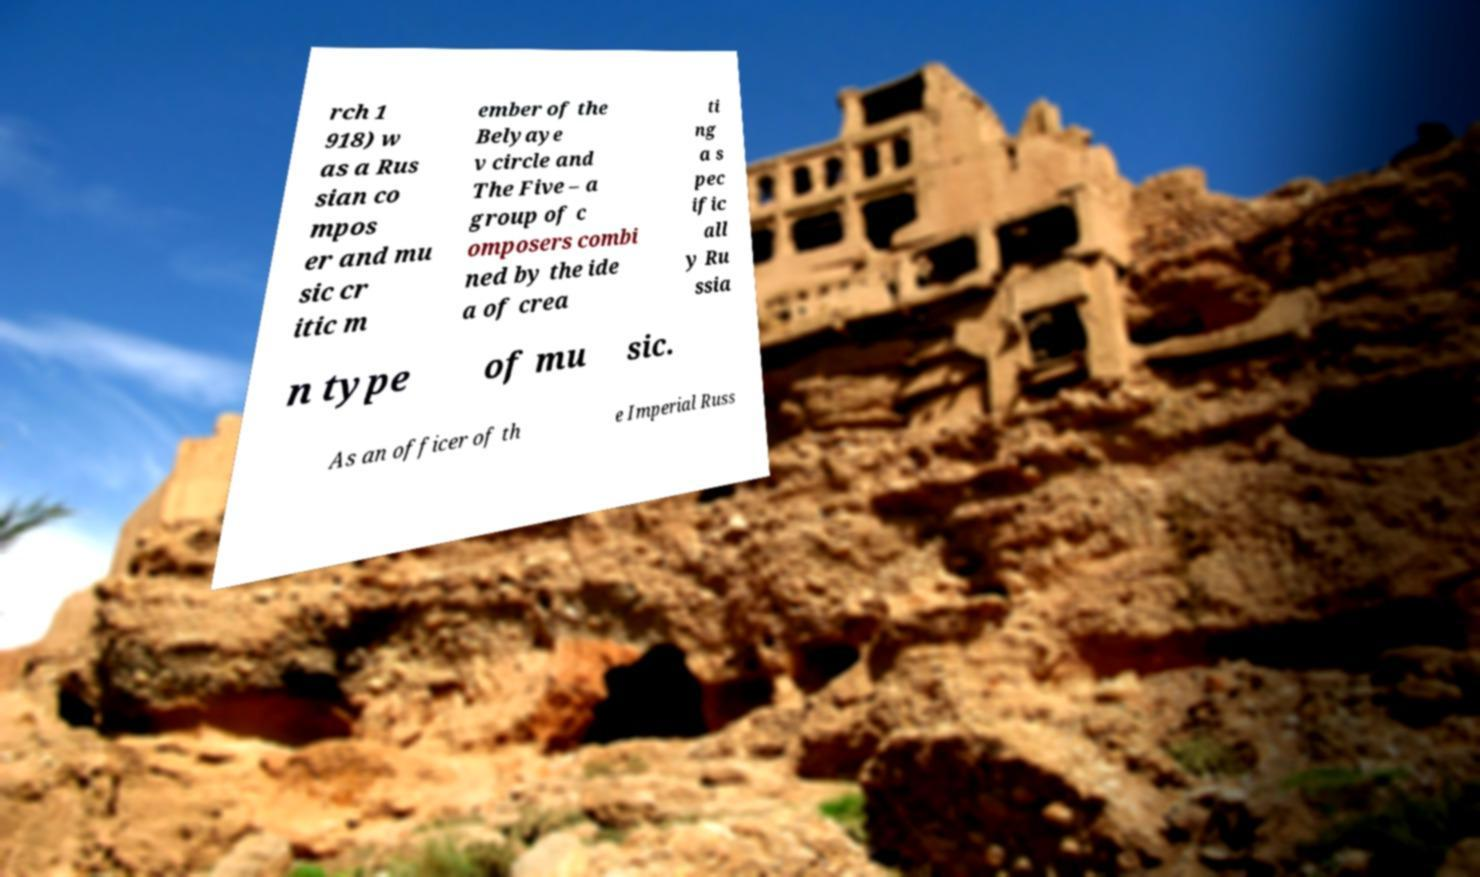Please identify and transcribe the text found in this image. rch 1 918) w as a Rus sian co mpos er and mu sic cr itic m ember of the Belyaye v circle and The Five – a group of c omposers combi ned by the ide a of crea ti ng a s pec ific all y Ru ssia n type of mu sic. As an officer of th e Imperial Russ 